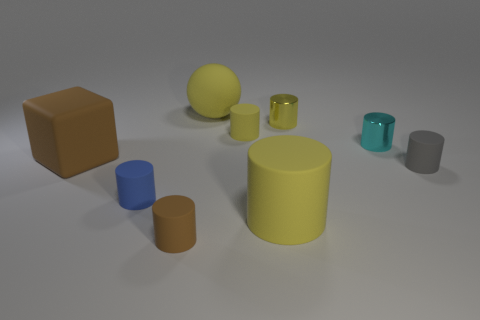What is the material of the thing that is both behind the tiny gray matte object and to the left of the large yellow sphere?
Give a very brief answer. Rubber. Is the tiny gray cylinder made of the same material as the cube?
Offer a very short reply. Yes. What number of gray cylinders are the same size as the blue cylinder?
Provide a short and direct response. 1. Are there the same number of small blue rubber cylinders that are on the left side of the rubber sphere and blue shiny blocks?
Provide a succinct answer. No. How many large matte things are in front of the small blue matte cylinder and behind the small blue matte thing?
Make the answer very short. 0. There is a brown matte thing to the left of the small blue thing; does it have the same shape as the tiny gray rubber object?
Provide a short and direct response. No. There is a blue thing that is the same size as the cyan shiny thing; what is it made of?
Offer a terse response. Rubber. Are there the same number of tiny cyan cylinders that are on the right side of the large rubber block and tiny brown rubber cylinders behind the yellow metallic object?
Give a very brief answer. No. What number of large matte blocks are to the right of the brown object behind the big yellow matte object in front of the small gray thing?
Your answer should be very brief. 0. There is a big matte cylinder; does it have the same color as the small rubber cylinder behind the small gray rubber object?
Provide a short and direct response. Yes. 